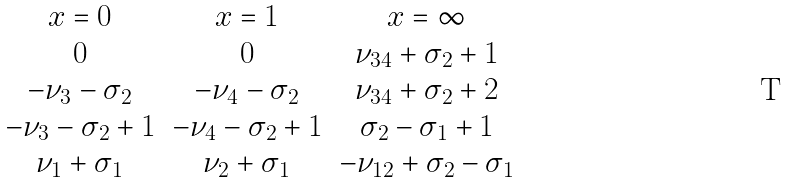<formula> <loc_0><loc_0><loc_500><loc_500>\begin{matrix} x = 0 & x = 1 & x = \infty \\ 0 & 0 & \nu _ { 3 4 } + \sigma _ { 2 } + 1 \\ - \nu _ { 3 } - \sigma _ { 2 } & - \nu _ { 4 } - \sigma _ { 2 } & \nu _ { 3 4 } + \sigma _ { 2 } + 2 \\ - \nu _ { 3 } - \sigma _ { 2 } + 1 & - \nu _ { 4 } - \sigma _ { 2 } + 1 & \sigma _ { 2 } - \sigma _ { 1 } + 1 \\ \nu _ { 1 } + \sigma _ { 1 } & \nu _ { 2 } + \sigma _ { 1 } & - \nu _ { 1 2 } + \sigma _ { 2 } - \sigma _ { 1 } \end{matrix}</formula> 